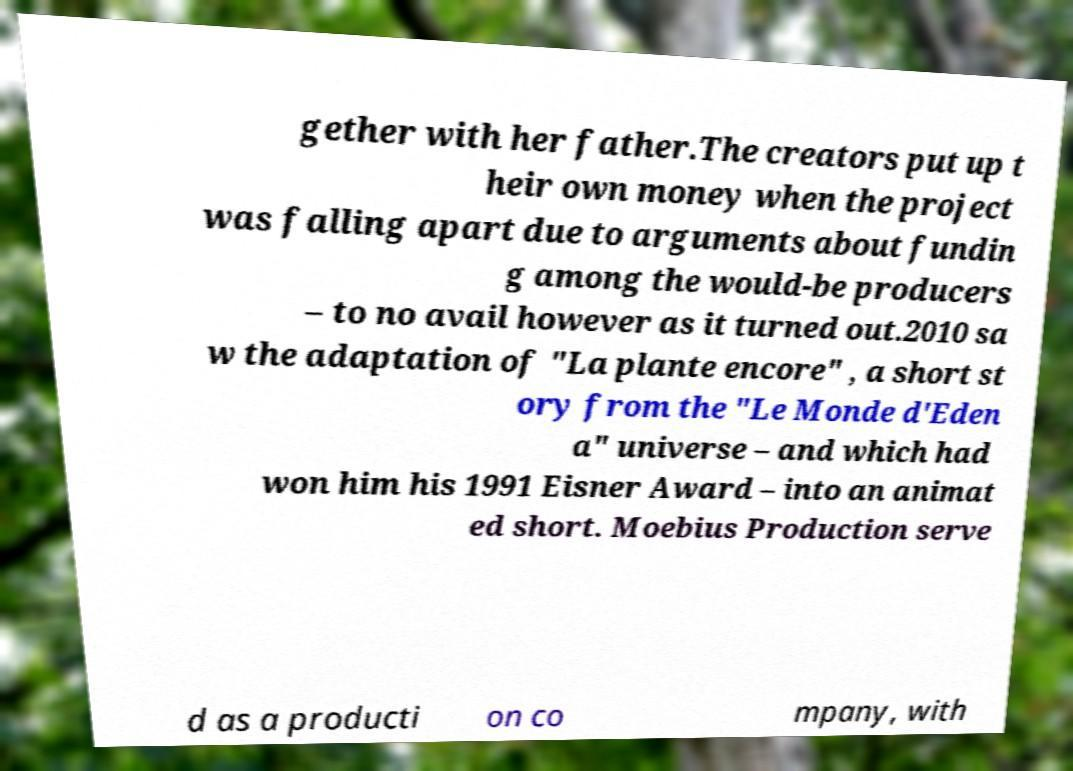Could you extract and type out the text from this image? gether with her father.The creators put up t heir own money when the project was falling apart due to arguments about fundin g among the would-be producers – to no avail however as it turned out.2010 sa w the adaptation of "La plante encore" , a short st ory from the "Le Monde d'Eden a" universe – and which had won him his 1991 Eisner Award – into an animat ed short. Moebius Production serve d as a producti on co mpany, with 